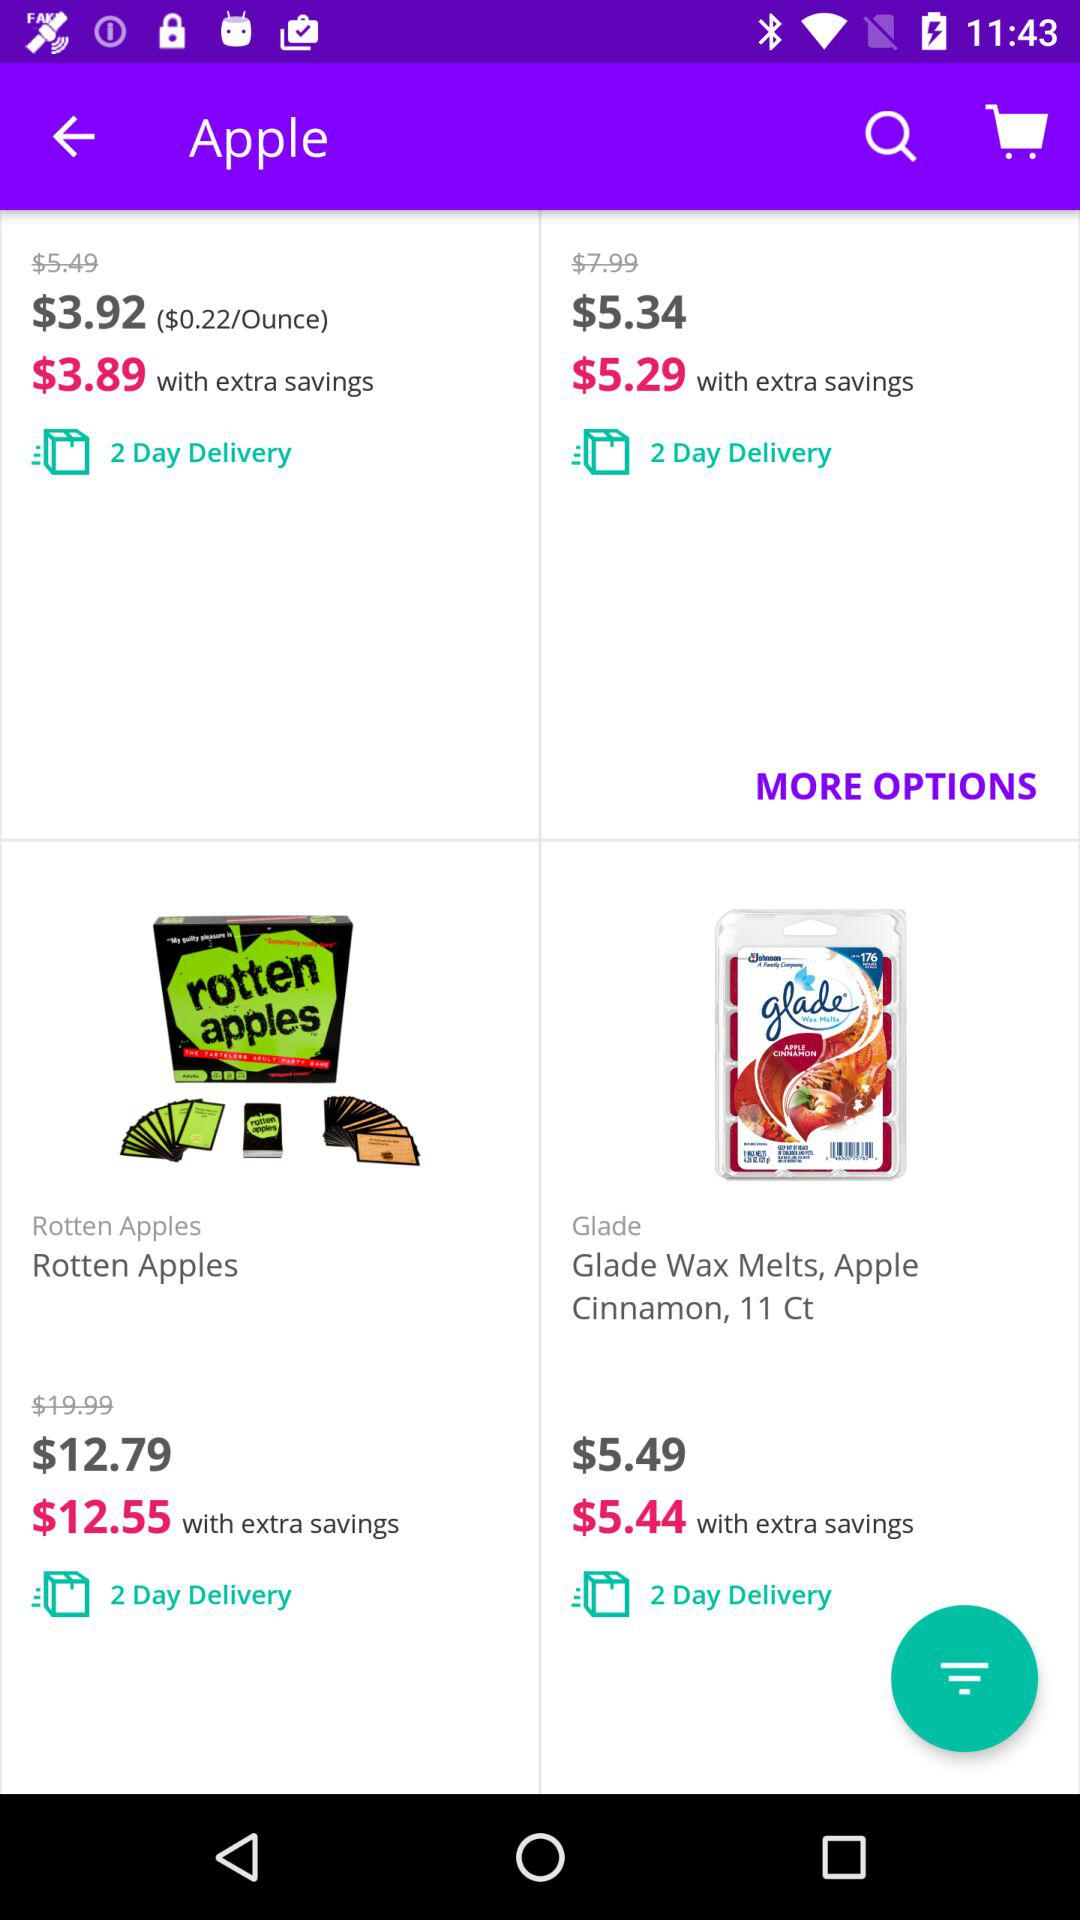What is the cost of "Glade Wax Melts, Apple Cinnamon,11 Ct"? The cost is $5.49. 